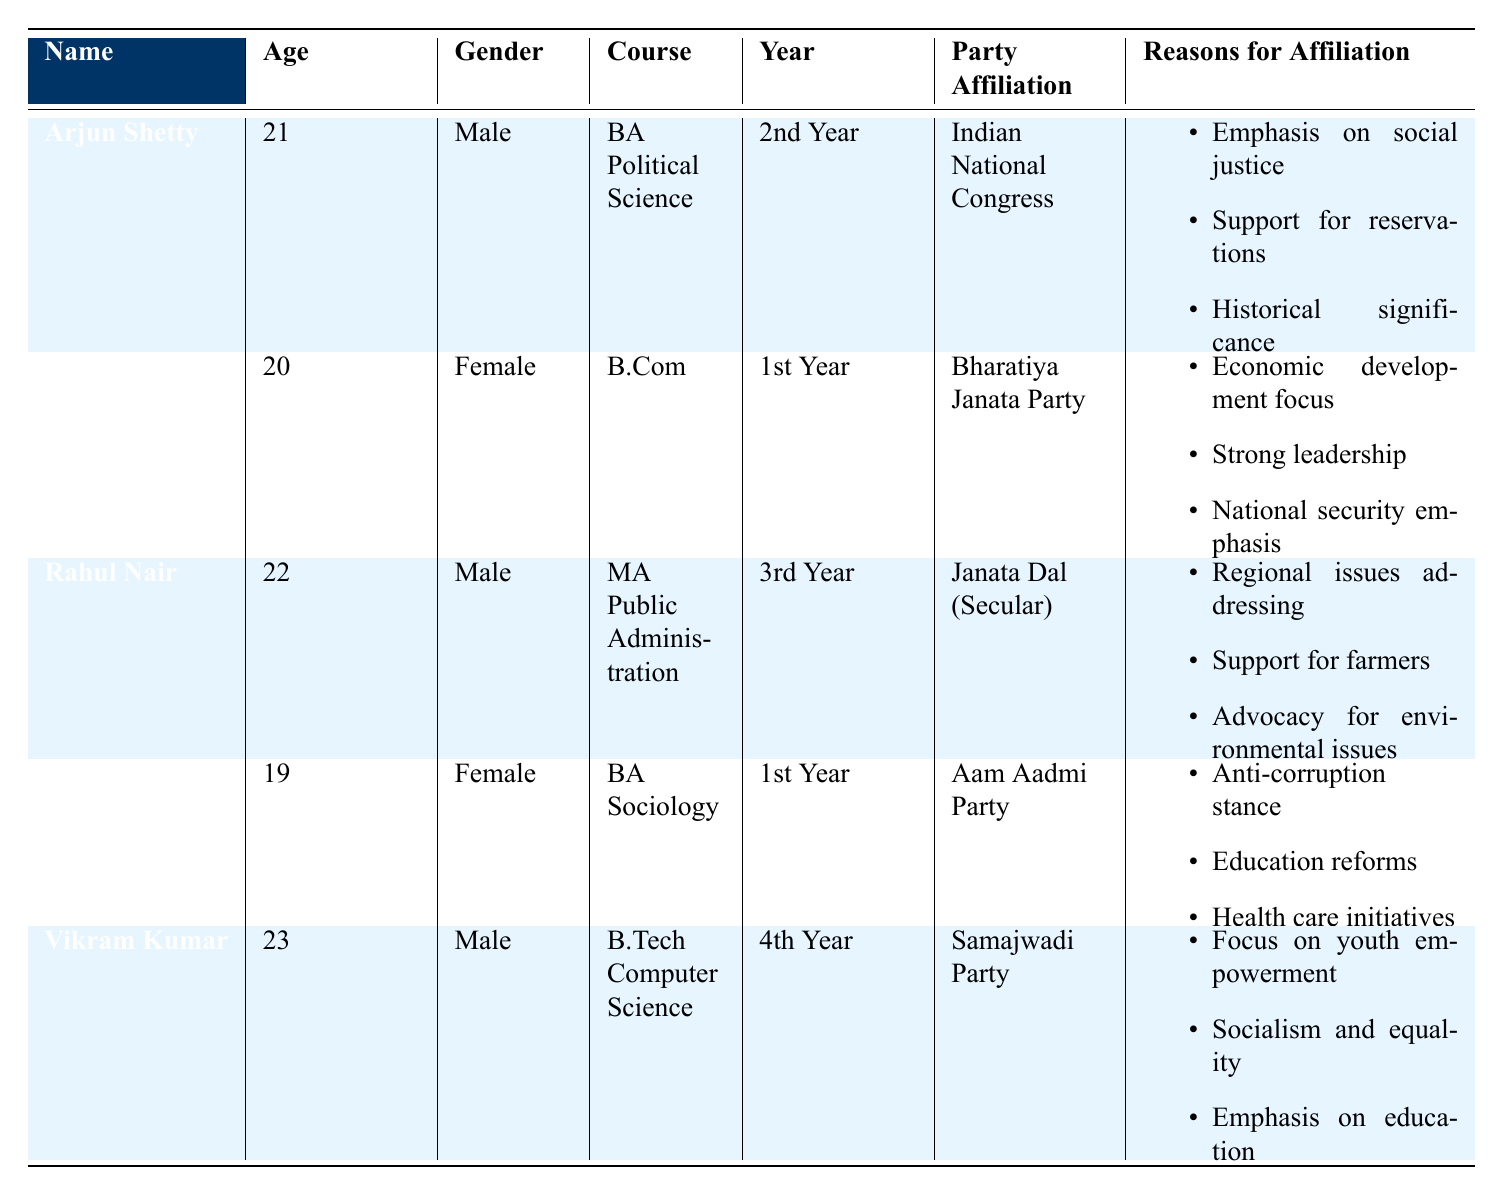What is the party affiliation of Arjun Shetty? Arjun Shetty is listed under Party Affiliation in the table as "Indian National Congress". Therefore, his party affiliation can be directly retrieved from the relevant row in the table.
Answer: Indian National Congress How many students are affiliated with the Bharatiya Janata Party? By examining the table, we see only one student, Lakshmi Rao, is affiliated with the Bharatiya Janata Party. This information is found directly in the row related to her.
Answer: 1 What are the reasons for Vikram Kumar's affiliation with the Samajwadi Party? The reasons for Vikram Kumar's party affiliation are provided in the table under the "Reasons for Affiliation" column. Reading that row shows three reasons: "Focus on youth empowerment," "Socialism and equality," and "Emphasis on education."
Answer: Focus on youth empowerment, Socialism and equality, Emphasis on education Is Priya Menon affiliated with the Aam Aadmi Party? The table confirms that Priya Menon is indeed affiliated with the Aam Aadmi Party, which is clearly stated in her row under Party Affiliation.
Answer: Yes Which political party has most students affiliated to it? To answer this, we analyze the entire table. We find that each political party has just one student affiliated to it; hence, there is no party with multiple affiliations among the students listed in the table.
Answer: No party has more than one student affiliated 